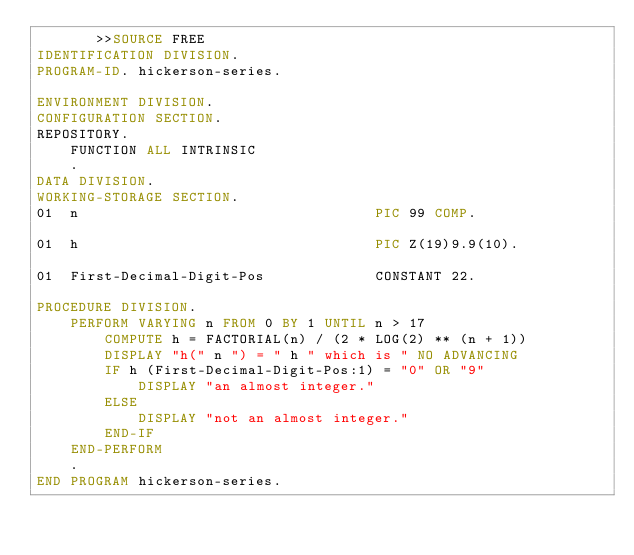Convert code to text. <code><loc_0><loc_0><loc_500><loc_500><_COBOL_>       >>SOURCE FREE
IDENTIFICATION DIVISION.
PROGRAM-ID. hickerson-series.

ENVIRONMENT DIVISION.
CONFIGURATION SECTION.
REPOSITORY.
    FUNCTION ALL INTRINSIC
    .
DATA DIVISION.
WORKING-STORAGE SECTION.
01  n                                   PIC 99 COMP.

01  h                                   PIC Z(19)9.9(10).

01  First-Decimal-Digit-Pos             CONSTANT 22.

PROCEDURE DIVISION.
    PERFORM VARYING n FROM 0 BY 1 UNTIL n > 17
        COMPUTE h = FACTORIAL(n) / (2 * LOG(2) ** (n + 1))
        DISPLAY "h(" n ") = " h " which is " NO ADVANCING
        IF h (First-Decimal-Digit-Pos:1) = "0" OR "9"
            DISPLAY "an almost integer."
        ELSE
            DISPLAY "not an almost integer."
        END-IF
    END-PERFORM
    .
END PROGRAM hickerson-series.
</code> 